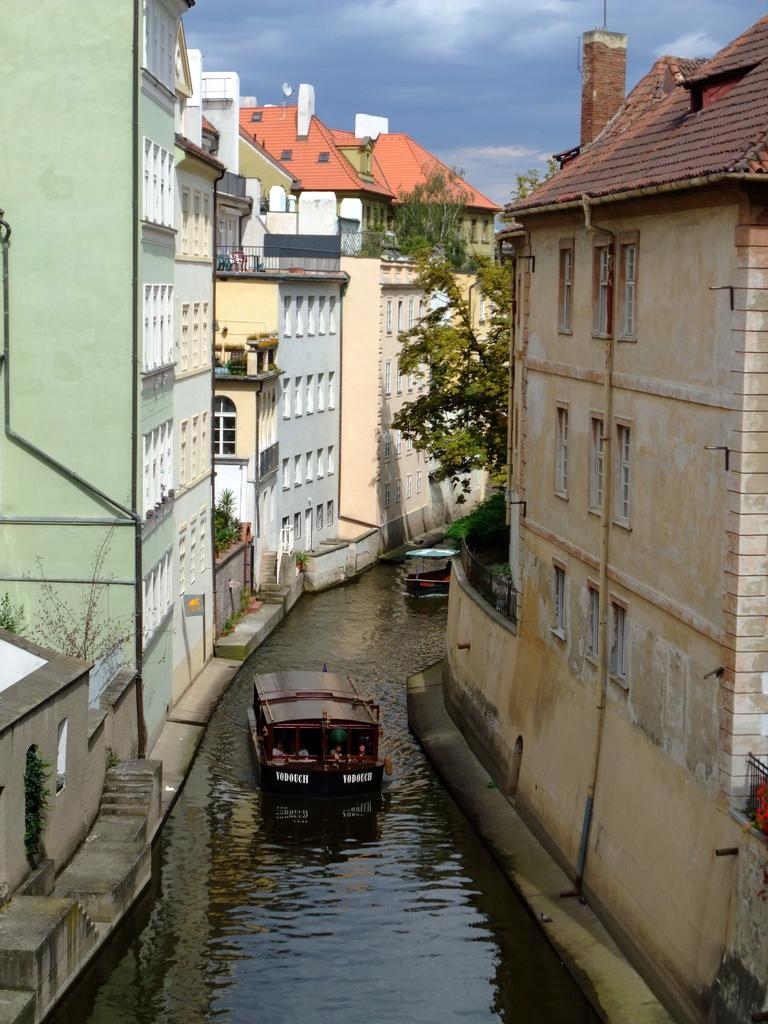What is the main element present in the image? There is water in the image. What can be seen floating on the water? There are boats in the water. What other structures are visible in the image? There are buildings and trees in the image. What can be seen in the background of the image? The sky is visible in the background of the image. How many rings are being worn by the servant in the image? There is no servant or rings present in the image. What type of train can be seen passing by in the image? There is no train visible in the image. 